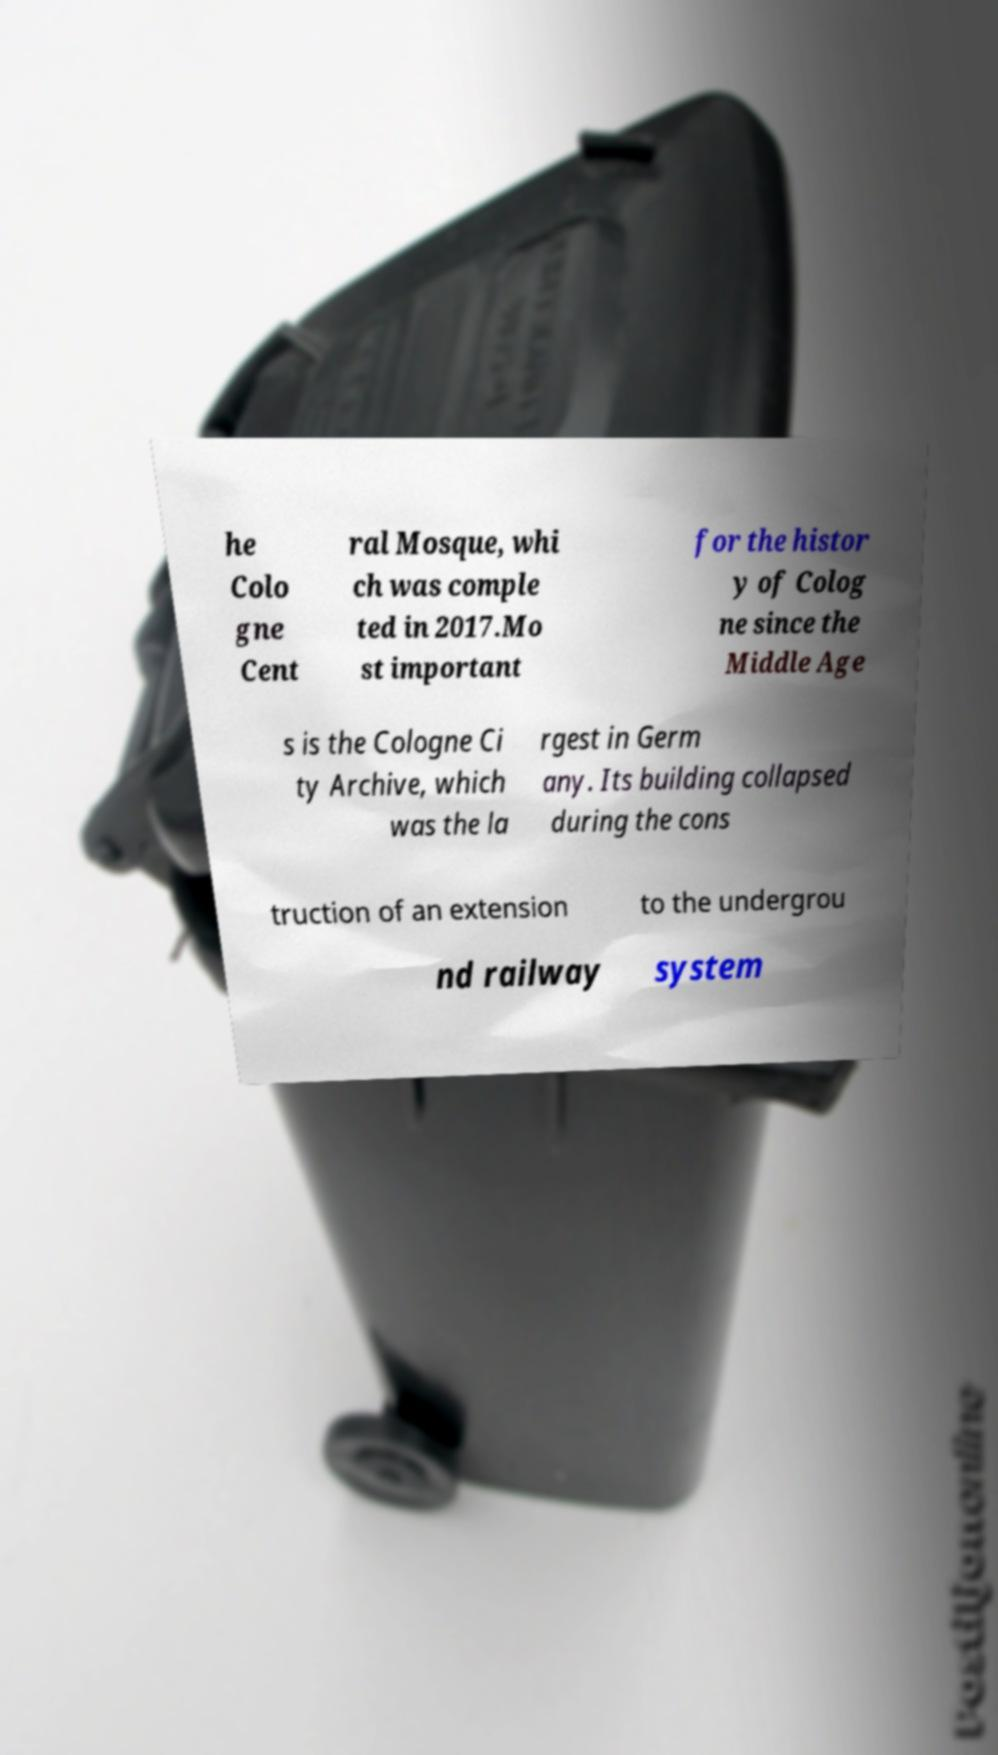Can you accurately transcribe the text from the provided image for me? he Colo gne Cent ral Mosque, whi ch was comple ted in 2017.Mo st important for the histor y of Colog ne since the Middle Age s is the Cologne Ci ty Archive, which was the la rgest in Germ any. Its building collapsed during the cons truction of an extension to the undergrou nd railway system 